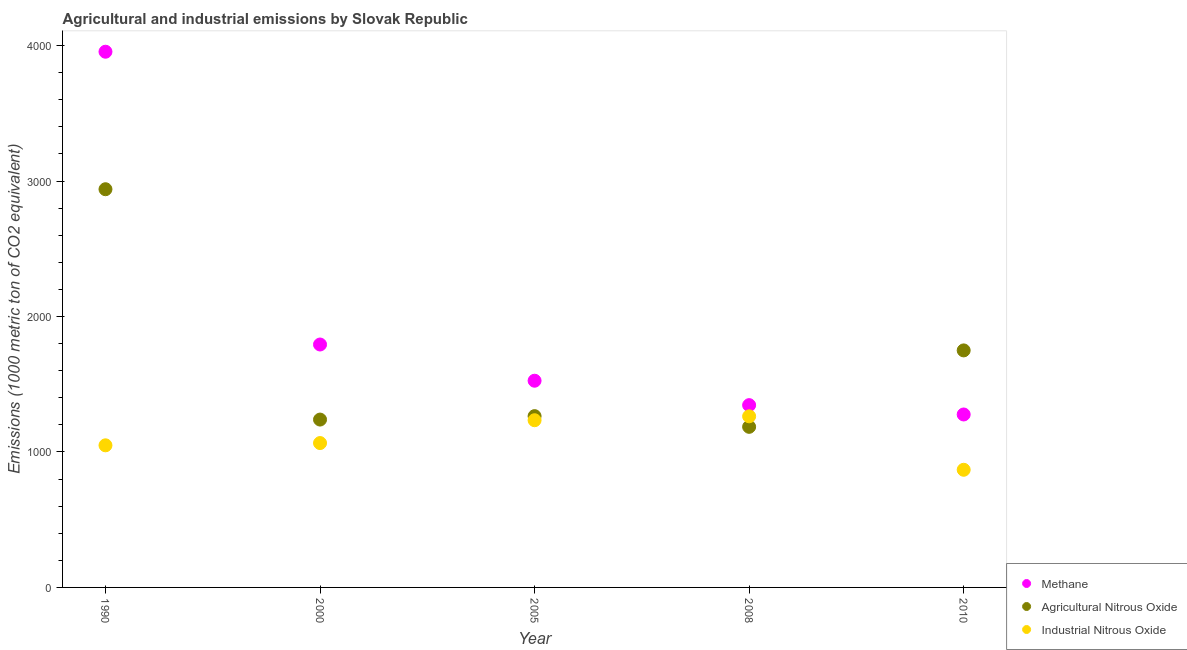How many different coloured dotlines are there?
Make the answer very short. 3. Is the number of dotlines equal to the number of legend labels?
Provide a short and direct response. Yes. What is the amount of agricultural nitrous oxide emissions in 2000?
Provide a succinct answer. 1239.1. Across all years, what is the maximum amount of methane emissions?
Keep it short and to the point. 3954.5. Across all years, what is the minimum amount of industrial nitrous oxide emissions?
Keep it short and to the point. 868.5. In which year was the amount of industrial nitrous oxide emissions minimum?
Keep it short and to the point. 2010. What is the total amount of methane emissions in the graph?
Your answer should be compact. 9896. What is the difference between the amount of industrial nitrous oxide emissions in 2000 and that in 2005?
Your answer should be very brief. -168.6. What is the difference between the amount of agricultural nitrous oxide emissions in 2010 and the amount of methane emissions in 2005?
Provide a succinct answer. 223.8. What is the average amount of industrial nitrous oxide emissions per year?
Give a very brief answer. 1096.12. In the year 2000, what is the difference between the amount of agricultural nitrous oxide emissions and amount of methane emissions?
Your response must be concise. -554.1. In how many years, is the amount of agricultural nitrous oxide emissions greater than 1200 metric ton?
Provide a short and direct response. 4. What is the ratio of the amount of agricultural nitrous oxide emissions in 1990 to that in 2005?
Your answer should be compact. 2.32. Is the amount of industrial nitrous oxide emissions in 2005 less than that in 2010?
Keep it short and to the point. No. Is the difference between the amount of agricultural nitrous oxide emissions in 2000 and 2005 greater than the difference between the amount of methane emissions in 2000 and 2005?
Offer a terse response. No. What is the difference between the highest and the second highest amount of agricultural nitrous oxide emissions?
Ensure brevity in your answer.  1189.8. What is the difference between the highest and the lowest amount of methane emissions?
Provide a succinct answer. 2677.8. In how many years, is the amount of methane emissions greater than the average amount of methane emissions taken over all years?
Keep it short and to the point. 1. Is the amount of industrial nitrous oxide emissions strictly greater than the amount of methane emissions over the years?
Your response must be concise. No. Is the amount of methane emissions strictly less than the amount of industrial nitrous oxide emissions over the years?
Your response must be concise. No. What is the difference between two consecutive major ticks on the Y-axis?
Make the answer very short. 1000. Are the values on the major ticks of Y-axis written in scientific E-notation?
Provide a short and direct response. No. Does the graph contain any zero values?
Offer a terse response. No. Does the graph contain grids?
Make the answer very short. No. Where does the legend appear in the graph?
Keep it short and to the point. Bottom right. How many legend labels are there?
Give a very brief answer. 3. How are the legend labels stacked?
Offer a terse response. Vertical. What is the title of the graph?
Make the answer very short. Agricultural and industrial emissions by Slovak Republic. Does "Social Protection" appear as one of the legend labels in the graph?
Your response must be concise. No. What is the label or title of the Y-axis?
Offer a terse response. Emissions (1000 metric ton of CO2 equivalent). What is the Emissions (1000 metric ton of CO2 equivalent) of Methane in 1990?
Your response must be concise. 3954.5. What is the Emissions (1000 metric ton of CO2 equivalent) in Agricultural Nitrous Oxide in 1990?
Offer a very short reply. 2939.5. What is the Emissions (1000 metric ton of CO2 equivalent) of Industrial Nitrous Oxide in 1990?
Ensure brevity in your answer.  1049. What is the Emissions (1000 metric ton of CO2 equivalent) of Methane in 2000?
Offer a very short reply. 1793.2. What is the Emissions (1000 metric ton of CO2 equivalent) in Agricultural Nitrous Oxide in 2000?
Provide a short and direct response. 1239.1. What is the Emissions (1000 metric ton of CO2 equivalent) in Industrial Nitrous Oxide in 2000?
Make the answer very short. 1065.7. What is the Emissions (1000 metric ton of CO2 equivalent) in Methane in 2005?
Provide a succinct answer. 1525.9. What is the Emissions (1000 metric ton of CO2 equivalent) of Agricultural Nitrous Oxide in 2005?
Your answer should be very brief. 1264.5. What is the Emissions (1000 metric ton of CO2 equivalent) in Industrial Nitrous Oxide in 2005?
Your answer should be very brief. 1234.3. What is the Emissions (1000 metric ton of CO2 equivalent) of Methane in 2008?
Make the answer very short. 1345.7. What is the Emissions (1000 metric ton of CO2 equivalent) in Agricultural Nitrous Oxide in 2008?
Your response must be concise. 1185.5. What is the Emissions (1000 metric ton of CO2 equivalent) of Industrial Nitrous Oxide in 2008?
Ensure brevity in your answer.  1263.1. What is the Emissions (1000 metric ton of CO2 equivalent) of Methane in 2010?
Your response must be concise. 1276.7. What is the Emissions (1000 metric ton of CO2 equivalent) of Agricultural Nitrous Oxide in 2010?
Provide a short and direct response. 1749.7. What is the Emissions (1000 metric ton of CO2 equivalent) in Industrial Nitrous Oxide in 2010?
Give a very brief answer. 868.5. Across all years, what is the maximum Emissions (1000 metric ton of CO2 equivalent) in Methane?
Make the answer very short. 3954.5. Across all years, what is the maximum Emissions (1000 metric ton of CO2 equivalent) in Agricultural Nitrous Oxide?
Offer a very short reply. 2939.5. Across all years, what is the maximum Emissions (1000 metric ton of CO2 equivalent) of Industrial Nitrous Oxide?
Make the answer very short. 1263.1. Across all years, what is the minimum Emissions (1000 metric ton of CO2 equivalent) in Methane?
Your response must be concise. 1276.7. Across all years, what is the minimum Emissions (1000 metric ton of CO2 equivalent) in Agricultural Nitrous Oxide?
Offer a very short reply. 1185.5. Across all years, what is the minimum Emissions (1000 metric ton of CO2 equivalent) in Industrial Nitrous Oxide?
Offer a terse response. 868.5. What is the total Emissions (1000 metric ton of CO2 equivalent) of Methane in the graph?
Your answer should be very brief. 9896. What is the total Emissions (1000 metric ton of CO2 equivalent) of Agricultural Nitrous Oxide in the graph?
Ensure brevity in your answer.  8378.3. What is the total Emissions (1000 metric ton of CO2 equivalent) in Industrial Nitrous Oxide in the graph?
Your answer should be compact. 5480.6. What is the difference between the Emissions (1000 metric ton of CO2 equivalent) of Methane in 1990 and that in 2000?
Your answer should be very brief. 2161.3. What is the difference between the Emissions (1000 metric ton of CO2 equivalent) in Agricultural Nitrous Oxide in 1990 and that in 2000?
Your response must be concise. 1700.4. What is the difference between the Emissions (1000 metric ton of CO2 equivalent) of Industrial Nitrous Oxide in 1990 and that in 2000?
Offer a terse response. -16.7. What is the difference between the Emissions (1000 metric ton of CO2 equivalent) in Methane in 1990 and that in 2005?
Give a very brief answer. 2428.6. What is the difference between the Emissions (1000 metric ton of CO2 equivalent) in Agricultural Nitrous Oxide in 1990 and that in 2005?
Make the answer very short. 1675. What is the difference between the Emissions (1000 metric ton of CO2 equivalent) in Industrial Nitrous Oxide in 1990 and that in 2005?
Offer a terse response. -185.3. What is the difference between the Emissions (1000 metric ton of CO2 equivalent) in Methane in 1990 and that in 2008?
Make the answer very short. 2608.8. What is the difference between the Emissions (1000 metric ton of CO2 equivalent) of Agricultural Nitrous Oxide in 1990 and that in 2008?
Give a very brief answer. 1754. What is the difference between the Emissions (1000 metric ton of CO2 equivalent) in Industrial Nitrous Oxide in 1990 and that in 2008?
Give a very brief answer. -214.1. What is the difference between the Emissions (1000 metric ton of CO2 equivalent) of Methane in 1990 and that in 2010?
Provide a short and direct response. 2677.8. What is the difference between the Emissions (1000 metric ton of CO2 equivalent) of Agricultural Nitrous Oxide in 1990 and that in 2010?
Make the answer very short. 1189.8. What is the difference between the Emissions (1000 metric ton of CO2 equivalent) in Industrial Nitrous Oxide in 1990 and that in 2010?
Keep it short and to the point. 180.5. What is the difference between the Emissions (1000 metric ton of CO2 equivalent) in Methane in 2000 and that in 2005?
Your response must be concise. 267.3. What is the difference between the Emissions (1000 metric ton of CO2 equivalent) of Agricultural Nitrous Oxide in 2000 and that in 2005?
Keep it short and to the point. -25.4. What is the difference between the Emissions (1000 metric ton of CO2 equivalent) in Industrial Nitrous Oxide in 2000 and that in 2005?
Ensure brevity in your answer.  -168.6. What is the difference between the Emissions (1000 metric ton of CO2 equivalent) in Methane in 2000 and that in 2008?
Your response must be concise. 447.5. What is the difference between the Emissions (1000 metric ton of CO2 equivalent) of Agricultural Nitrous Oxide in 2000 and that in 2008?
Ensure brevity in your answer.  53.6. What is the difference between the Emissions (1000 metric ton of CO2 equivalent) in Industrial Nitrous Oxide in 2000 and that in 2008?
Your answer should be very brief. -197.4. What is the difference between the Emissions (1000 metric ton of CO2 equivalent) of Methane in 2000 and that in 2010?
Keep it short and to the point. 516.5. What is the difference between the Emissions (1000 metric ton of CO2 equivalent) in Agricultural Nitrous Oxide in 2000 and that in 2010?
Ensure brevity in your answer.  -510.6. What is the difference between the Emissions (1000 metric ton of CO2 equivalent) of Industrial Nitrous Oxide in 2000 and that in 2010?
Your response must be concise. 197.2. What is the difference between the Emissions (1000 metric ton of CO2 equivalent) of Methane in 2005 and that in 2008?
Give a very brief answer. 180.2. What is the difference between the Emissions (1000 metric ton of CO2 equivalent) in Agricultural Nitrous Oxide in 2005 and that in 2008?
Your answer should be very brief. 79. What is the difference between the Emissions (1000 metric ton of CO2 equivalent) of Industrial Nitrous Oxide in 2005 and that in 2008?
Offer a very short reply. -28.8. What is the difference between the Emissions (1000 metric ton of CO2 equivalent) of Methane in 2005 and that in 2010?
Provide a succinct answer. 249.2. What is the difference between the Emissions (1000 metric ton of CO2 equivalent) in Agricultural Nitrous Oxide in 2005 and that in 2010?
Ensure brevity in your answer.  -485.2. What is the difference between the Emissions (1000 metric ton of CO2 equivalent) in Industrial Nitrous Oxide in 2005 and that in 2010?
Provide a short and direct response. 365.8. What is the difference between the Emissions (1000 metric ton of CO2 equivalent) of Agricultural Nitrous Oxide in 2008 and that in 2010?
Ensure brevity in your answer.  -564.2. What is the difference between the Emissions (1000 metric ton of CO2 equivalent) in Industrial Nitrous Oxide in 2008 and that in 2010?
Provide a short and direct response. 394.6. What is the difference between the Emissions (1000 metric ton of CO2 equivalent) of Methane in 1990 and the Emissions (1000 metric ton of CO2 equivalent) of Agricultural Nitrous Oxide in 2000?
Keep it short and to the point. 2715.4. What is the difference between the Emissions (1000 metric ton of CO2 equivalent) of Methane in 1990 and the Emissions (1000 metric ton of CO2 equivalent) of Industrial Nitrous Oxide in 2000?
Provide a short and direct response. 2888.8. What is the difference between the Emissions (1000 metric ton of CO2 equivalent) in Agricultural Nitrous Oxide in 1990 and the Emissions (1000 metric ton of CO2 equivalent) in Industrial Nitrous Oxide in 2000?
Your answer should be compact. 1873.8. What is the difference between the Emissions (1000 metric ton of CO2 equivalent) of Methane in 1990 and the Emissions (1000 metric ton of CO2 equivalent) of Agricultural Nitrous Oxide in 2005?
Give a very brief answer. 2690. What is the difference between the Emissions (1000 metric ton of CO2 equivalent) in Methane in 1990 and the Emissions (1000 metric ton of CO2 equivalent) in Industrial Nitrous Oxide in 2005?
Provide a short and direct response. 2720.2. What is the difference between the Emissions (1000 metric ton of CO2 equivalent) of Agricultural Nitrous Oxide in 1990 and the Emissions (1000 metric ton of CO2 equivalent) of Industrial Nitrous Oxide in 2005?
Your answer should be very brief. 1705.2. What is the difference between the Emissions (1000 metric ton of CO2 equivalent) in Methane in 1990 and the Emissions (1000 metric ton of CO2 equivalent) in Agricultural Nitrous Oxide in 2008?
Provide a succinct answer. 2769. What is the difference between the Emissions (1000 metric ton of CO2 equivalent) of Methane in 1990 and the Emissions (1000 metric ton of CO2 equivalent) of Industrial Nitrous Oxide in 2008?
Your response must be concise. 2691.4. What is the difference between the Emissions (1000 metric ton of CO2 equivalent) in Agricultural Nitrous Oxide in 1990 and the Emissions (1000 metric ton of CO2 equivalent) in Industrial Nitrous Oxide in 2008?
Offer a very short reply. 1676.4. What is the difference between the Emissions (1000 metric ton of CO2 equivalent) in Methane in 1990 and the Emissions (1000 metric ton of CO2 equivalent) in Agricultural Nitrous Oxide in 2010?
Offer a terse response. 2204.8. What is the difference between the Emissions (1000 metric ton of CO2 equivalent) in Methane in 1990 and the Emissions (1000 metric ton of CO2 equivalent) in Industrial Nitrous Oxide in 2010?
Ensure brevity in your answer.  3086. What is the difference between the Emissions (1000 metric ton of CO2 equivalent) of Agricultural Nitrous Oxide in 1990 and the Emissions (1000 metric ton of CO2 equivalent) of Industrial Nitrous Oxide in 2010?
Your response must be concise. 2071. What is the difference between the Emissions (1000 metric ton of CO2 equivalent) in Methane in 2000 and the Emissions (1000 metric ton of CO2 equivalent) in Agricultural Nitrous Oxide in 2005?
Make the answer very short. 528.7. What is the difference between the Emissions (1000 metric ton of CO2 equivalent) in Methane in 2000 and the Emissions (1000 metric ton of CO2 equivalent) in Industrial Nitrous Oxide in 2005?
Provide a succinct answer. 558.9. What is the difference between the Emissions (1000 metric ton of CO2 equivalent) of Methane in 2000 and the Emissions (1000 metric ton of CO2 equivalent) of Agricultural Nitrous Oxide in 2008?
Your response must be concise. 607.7. What is the difference between the Emissions (1000 metric ton of CO2 equivalent) of Methane in 2000 and the Emissions (1000 metric ton of CO2 equivalent) of Industrial Nitrous Oxide in 2008?
Ensure brevity in your answer.  530.1. What is the difference between the Emissions (1000 metric ton of CO2 equivalent) in Methane in 2000 and the Emissions (1000 metric ton of CO2 equivalent) in Agricultural Nitrous Oxide in 2010?
Your answer should be compact. 43.5. What is the difference between the Emissions (1000 metric ton of CO2 equivalent) of Methane in 2000 and the Emissions (1000 metric ton of CO2 equivalent) of Industrial Nitrous Oxide in 2010?
Your response must be concise. 924.7. What is the difference between the Emissions (1000 metric ton of CO2 equivalent) of Agricultural Nitrous Oxide in 2000 and the Emissions (1000 metric ton of CO2 equivalent) of Industrial Nitrous Oxide in 2010?
Ensure brevity in your answer.  370.6. What is the difference between the Emissions (1000 metric ton of CO2 equivalent) in Methane in 2005 and the Emissions (1000 metric ton of CO2 equivalent) in Agricultural Nitrous Oxide in 2008?
Your answer should be compact. 340.4. What is the difference between the Emissions (1000 metric ton of CO2 equivalent) of Methane in 2005 and the Emissions (1000 metric ton of CO2 equivalent) of Industrial Nitrous Oxide in 2008?
Provide a succinct answer. 262.8. What is the difference between the Emissions (1000 metric ton of CO2 equivalent) of Agricultural Nitrous Oxide in 2005 and the Emissions (1000 metric ton of CO2 equivalent) of Industrial Nitrous Oxide in 2008?
Offer a very short reply. 1.4. What is the difference between the Emissions (1000 metric ton of CO2 equivalent) in Methane in 2005 and the Emissions (1000 metric ton of CO2 equivalent) in Agricultural Nitrous Oxide in 2010?
Your answer should be very brief. -223.8. What is the difference between the Emissions (1000 metric ton of CO2 equivalent) in Methane in 2005 and the Emissions (1000 metric ton of CO2 equivalent) in Industrial Nitrous Oxide in 2010?
Ensure brevity in your answer.  657.4. What is the difference between the Emissions (1000 metric ton of CO2 equivalent) of Agricultural Nitrous Oxide in 2005 and the Emissions (1000 metric ton of CO2 equivalent) of Industrial Nitrous Oxide in 2010?
Ensure brevity in your answer.  396. What is the difference between the Emissions (1000 metric ton of CO2 equivalent) of Methane in 2008 and the Emissions (1000 metric ton of CO2 equivalent) of Agricultural Nitrous Oxide in 2010?
Make the answer very short. -404. What is the difference between the Emissions (1000 metric ton of CO2 equivalent) of Methane in 2008 and the Emissions (1000 metric ton of CO2 equivalent) of Industrial Nitrous Oxide in 2010?
Ensure brevity in your answer.  477.2. What is the difference between the Emissions (1000 metric ton of CO2 equivalent) in Agricultural Nitrous Oxide in 2008 and the Emissions (1000 metric ton of CO2 equivalent) in Industrial Nitrous Oxide in 2010?
Offer a terse response. 317. What is the average Emissions (1000 metric ton of CO2 equivalent) in Methane per year?
Your answer should be compact. 1979.2. What is the average Emissions (1000 metric ton of CO2 equivalent) of Agricultural Nitrous Oxide per year?
Your answer should be very brief. 1675.66. What is the average Emissions (1000 metric ton of CO2 equivalent) of Industrial Nitrous Oxide per year?
Make the answer very short. 1096.12. In the year 1990, what is the difference between the Emissions (1000 metric ton of CO2 equivalent) in Methane and Emissions (1000 metric ton of CO2 equivalent) in Agricultural Nitrous Oxide?
Your answer should be compact. 1015. In the year 1990, what is the difference between the Emissions (1000 metric ton of CO2 equivalent) in Methane and Emissions (1000 metric ton of CO2 equivalent) in Industrial Nitrous Oxide?
Provide a short and direct response. 2905.5. In the year 1990, what is the difference between the Emissions (1000 metric ton of CO2 equivalent) in Agricultural Nitrous Oxide and Emissions (1000 metric ton of CO2 equivalent) in Industrial Nitrous Oxide?
Provide a short and direct response. 1890.5. In the year 2000, what is the difference between the Emissions (1000 metric ton of CO2 equivalent) in Methane and Emissions (1000 metric ton of CO2 equivalent) in Agricultural Nitrous Oxide?
Ensure brevity in your answer.  554.1. In the year 2000, what is the difference between the Emissions (1000 metric ton of CO2 equivalent) of Methane and Emissions (1000 metric ton of CO2 equivalent) of Industrial Nitrous Oxide?
Offer a terse response. 727.5. In the year 2000, what is the difference between the Emissions (1000 metric ton of CO2 equivalent) in Agricultural Nitrous Oxide and Emissions (1000 metric ton of CO2 equivalent) in Industrial Nitrous Oxide?
Give a very brief answer. 173.4. In the year 2005, what is the difference between the Emissions (1000 metric ton of CO2 equivalent) of Methane and Emissions (1000 metric ton of CO2 equivalent) of Agricultural Nitrous Oxide?
Ensure brevity in your answer.  261.4. In the year 2005, what is the difference between the Emissions (1000 metric ton of CO2 equivalent) of Methane and Emissions (1000 metric ton of CO2 equivalent) of Industrial Nitrous Oxide?
Give a very brief answer. 291.6. In the year 2005, what is the difference between the Emissions (1000 metric ton of CO2 equivalent) in Agricultural Nitrous Oxide and Emissions (1000 metric ton of CO2 equivalent) in Industrial Nitrous Oxide?
Provide a short and direct response. 30.2. In the year 2008, what is the difference between the Emissions (1000 metric ton of CO2 equivalent) of Methane and Emissions (1000 metric ton of CO2 equivalent) of Agricultural Nitrous Oxide?
Provide a succinct answer. 160.2. In the year 2008, what is the difference between the Emissions (1000 metric ton of CO2 equivalent) of Methane and Emissions (1000 metric ton of CO2 equivalent) of Industrial Nitrous Oxide?
Offer a very short reply. 82.6. In the year 2008, what is the difference between the Emissions (1000 metric ton of CO2 equivalent) in Agricultural Nitrous Oxide and Emissions (1000 metric ton of CO2 equivalent) in Industrial Nitrous Oxide?
Your response must be concise. -77.6. In the year 2010, what is the difference between the Emissions (1000 metric ton of CO2 equivalent) of Methane and Emissions (1000 metric ton of CO2 equivalent) of Agricultural Nitrous Oxide?
Make the answer very short. -473. In the year 2010, what is the difference between the Emissions (1000 metric ton of CO2 equivalent) of Methane and Emissions (1000 metric ton of CO2 equivalent) of Industrial Nitrous Oxide?
Keep it short and to the point. 408.2. In the year 2010, what is the difference between the Emissions (1000 metric ton of CO2 equivalent) of Agricultural Nitrous Oxide and Emissions (1000 metric ton of CO2 equivalent) of Industrial Nitrous Oxide?
Ensure brevity in your answer.  881.2. What is the ratio of the Emissions (1000 metric ton of CO2 equivalent) in Methane in 1990 to that in 2000?
Make the answer very short. 2.21. What is the ratio of the Emissions (1000 metric ton of CO2 equivalent) of Agricultural Nitrous Oxide in 1990 to that in 2000?
Offer a terse response. 2.37. What is the ratio of the Emissions (1000 metric ton of CO2 equivalent) in Industrial Nitrous Oxide in 1990 to that in 2000?
Provide a succinct answer. 0.98. What is the ratio of the Emissions (1000 metric ton of CO2 equivalent) in Methane in 1990 to that in 2005?
Offer a terse response. 2.59. What is the ratio of the Emissions (1000 metric ton of CO2 equivalent) in Agricultural Nitrous Oxide in 1990 to that in 2005?
Ensure brevity in your answer.  2.32. What is the ratio of the Emissions (1000 metric ton of CO2 equivalent) of Industrial Nitrous Oxide in 1990 to that in 2005?
Provide a succinct answer. 0.85. What is the ratio of the Emissions (1000 metric ton of CO2 equivalent) of Methane in 1990 to that in 2008?
Offer a terse response. 2.94. What is the ratio of the Emissions (1000 metric ton of CO2 equivalent) in Agricultural Nitrous Oxide in 1990 to that in 2008?
Ensure brevity in your answer.  2.48. What is the ratio of the Emissions (1000 metric ton of CO2 equivalent) in Industrial Nitrous Oxide in 1990 to that in 2008?
Your response must be concise. 0.83. What is the ratio of the Emissions (1000 metric ton of CO2 equivalent) in Methane in 1990 to that in 2010?
Offer a terse response. 3.1. What is the ratio of the Emissions (1000 metric ton of CO2 equivalent) in Agricultural Nitrous Oxide in 1990 to that in 2010?
Offer a terse response. 1.68. What is the ratio of the Emissions (1000 metric ton of CO2 equivalent) in Industrial Nitrous Oxide in 1990 to that in 2010?
Offer a terse response. 1.21. What is the ratio of the Emissions (1000 metric ton of CO2 equivalent) of Methane in 2000 to that in 2005?
Offer a terse response. 1.18. What is the ratio of the Emissions (1000 metric ton of CO2 equivalent) of Agricultural Nitrous Oxide in 2000 to that in 2005?
Your response must be concise. 0.98. What is the ratio of the Emissions (1000 metric ton of CO2 equivalent) in Industrial Nitrous Oxide in 2000 to that in 2005?
Keep it short and to the point. 0.86. What is the ratio of the Emissions (1000 metric ton of CO2 equivalent) in Methane in 2000 to that in 2008?
Your response must be concise. 1.33. What is the ratio of the Emissions (1000 metric ton of CO2 equivalent) in Agricultural Nitrous Oxide in 2000 to that in 2008?
Give a very brief answer. 1.05. What is the ratio of the Emissions (1000 metric ton of CO2 equivalent) in Industrial Nitrous Oxide in 2000 to that in 2008?
Offer a very short reply. 0.84. What is the ratio of the Emissions (1000 metric ton of CO2 equivalent) in Methane in 2000 to that in 2010?
Offer a terse response. 1.4. What is the ratio of the Emissions (1000 metric ton of CO2 equivalent) in Agricultural Nitrous Oxide in 2000 to that in 2010?
Ensure brevity in your answer.  0.71. What is the ratio of the Emissions (1000 metric ton of CO2 equivalent) in Industrial Nitrous Oxide in 2000 to that in 2010?
Keep it short and to the point. 1.23. What is the ratio of the Emissions (1000 metric ton of CO2 equivalent) in Methane in 2005 to that in 2008?
Keep it short and to the point. 1.13. What is the ratio of the Emissions (1000 metric ton of CO2 equivalent) of Agricultural Nitrous Oxide in 2005 to that in 2008?
Keep it short and to the point. 1.07. What is the ratio of the Emissions (1000 metric ton of CO2 equivalent) in Industrial Nitrous Oxide in 2005 to that in 2008?
Provide a succinct answer. 0.98. What is the ratio of the Emissions (1000 metric ton of CO2 equivalent) in Methane in 2005 to that in 2010?
Your response must be concise. 1.2. What is the ratio of the Emissions (1000 metric ton of CO2 equivalent) of Agricultural Nitrous Oxide in 2005 to that in 2010?
Your answer should be very brief. 0.72. What is the ratio of the Emissions (1000 metric ton of CO2 equivalent) in Industrial Nitrous Oxide in 2005 to that in 2010?
Provide a short and direct response. 1.42. What is the ratio of the Emissions (1000 metric ton of CO2 equivalent) in Methane in 2008 to that in 2010?
Your response must be concise. 1.05. What is the ratio of the Emissions (1000 metric ton of CO2 equivalent) of Agricultural Nitrous Oxide in 2008 to that in 2010?
Your answer should be compact. 0.68. What is the ratio of the Emissions (1000 metric ton of CO2 equivalent) of Industrial Nitrous Oxide in 2008 to that in 2010?
Provide a succinct answer. 1.45. What is the difference between the highest and the second highest Emissions (1000 metric ton of CO2 equivalent) in Methane?
Provide a short and direct response. 2161.3. What is the difference between the highest and the second highest Emissions (1000 metric ton of CO2 equivalent) of Agricultural Nitrous Oxide?
Your response must be concise. 1189.8. What is the difference between the highest and the second highest Emissions (1000 metric ton of CO2 equivalent) in Industrial Nitrous Oxide?
Make the answer very short. 28.8. What is the difference between the highest and the lowest Emissions (1000 metric ton of CO2 equivalent) of Methane?
Keep it short and to the point. 2677.8. What is the difference between the highest and the lowest Emissions (1000 metric ton of CO2 equivalent) of Agricultural Nitrous Oxide?
Your answer should be compact. 1754. What is the difference between the highest and the lowest Emissions (1000 metric ton of CO2 equivalent) of Industrial Nitrous Oxide?
Your response must be concise. 394.6. 